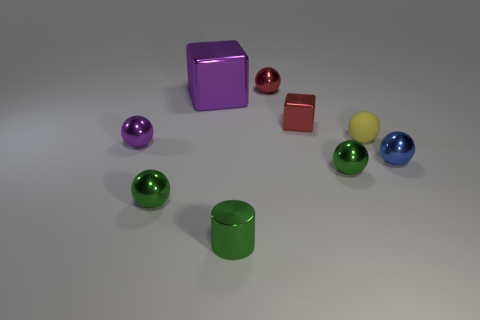Subtract all purple shiny balls. How many balls are left? 5 Subtract 2 spheres. How many spheres are left? 4 Subtract all purple balls. How many balls are left? 5 Subtract all gray balls. Subtract all red cubes. How many balls are left? 6 Subtract all cylinders. How many objects are left? 8 Add 3 blue spheres. How many blue spheres exist? 4 Subtract 0 purple cylinders. How many objects are left? 9 Subtract all green balls. Subtract all shiny cubes. How many objects are left? 5 Add 8 large purple metal cubes. How many large purple metal cubes are left? 9 